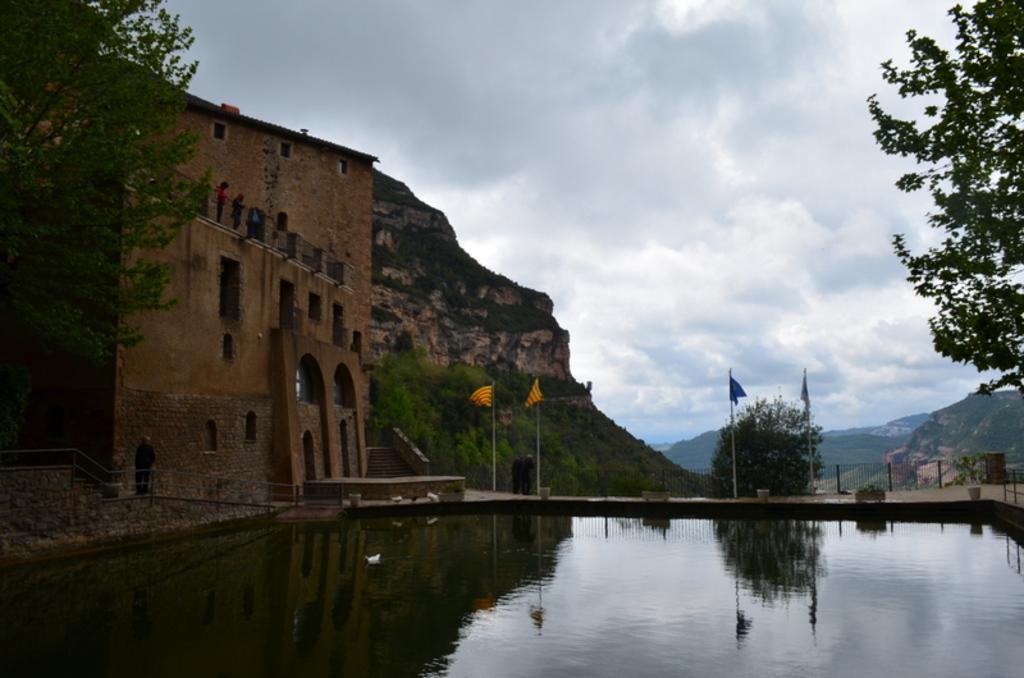In one or two sentences, can you explain what this image depicts? In this image in the middle, there are flags, trees, hills, building, poles. At the bottom there are waves, water, duck. At the top there are sky and clouds. 